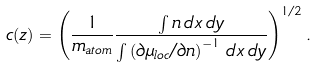Convert formula to latex. <formula><loc_0><loc_0><loc_500><loc_500>c ( z ) = \left ( \frac { 1 } { m _ { a t o m } } \frac { \int n \, d x \, d y } { \int \left ( \partial \mu _ { l o c } / \partial n \right ) ^ { - 1 } \, d x \, d y } \right ) ^ { 1 / 2 } .</formula> 